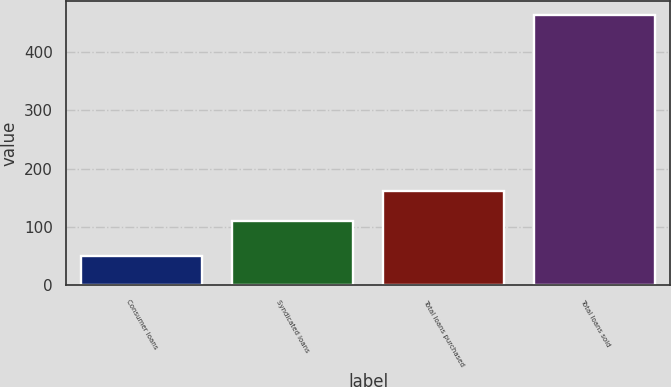Convert chart to OTSL. <chart><loc_0><loc_0><loc_500><loc_500><bar_chart><fcel>Consumer loans<fcel>Syndicated loans<fcel>Total loans purchased<fcel>Total loans sold<nl><fcel>51<fcel>111<fcel>162<fcel>464<nl></chart> 